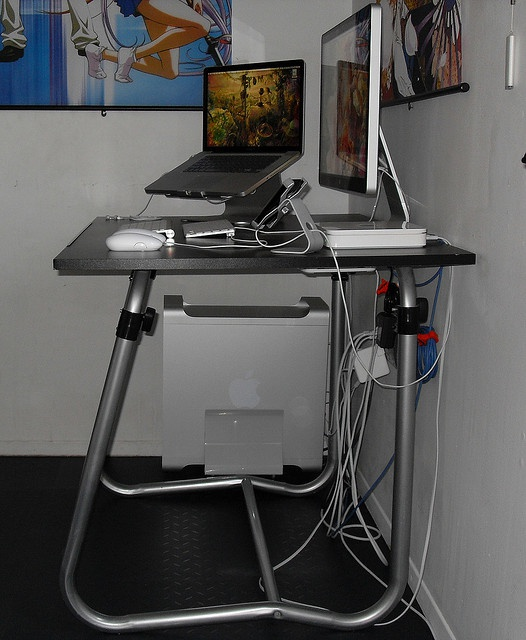Describe the objects in this image and their specific colors. I can see laptop in gray, black, olive, and maroon tones, tv in gray, black, lightgray, and darkgray tones, cell phone in gray, black, darkgray, and lightgray tones, mouse in gray, lightgray, and darkgray tones, and keyboard in gray, white, darkgray, and black tones in this image. 